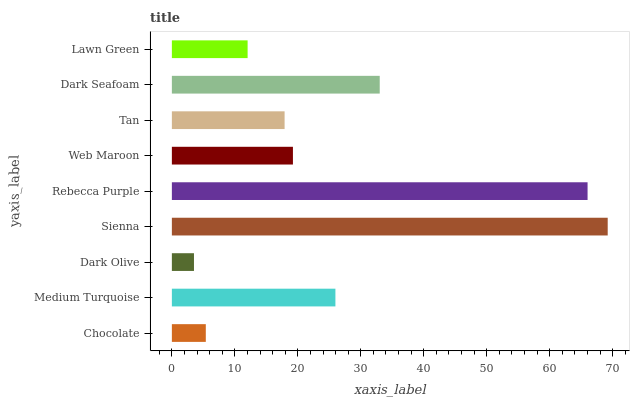Is Dark Olive the minimum?
Answer yes or no. Yes. Is Sienna the maximum?
Answer yes or no. Yes. Is Medium Turquoise the minimum?
Answer yes or no. No. Is Medium Turquoise the maximum?
Answer yes or no. No. Is Medium Turquoise greater than Chocolate?
Answer yes or no. Yes. Is Chocolate less than Medium Turquoise?
Answer yes or no. Yes. Is Chocolate greater than Medium Turquoise?
Answer yes or no. No. Is Medium Turquoise less than Chocolate?
Answer yes or no. No. Is Web Maroon the high median?
Answer yes or no. Yes. Is Web Maroon the low median?
Answer yes or no. Yes. Is Dark Seafoam the high median?
Answer yes or no. No. Is Rebecca Purple the low median?
Answer yes or no. No. 